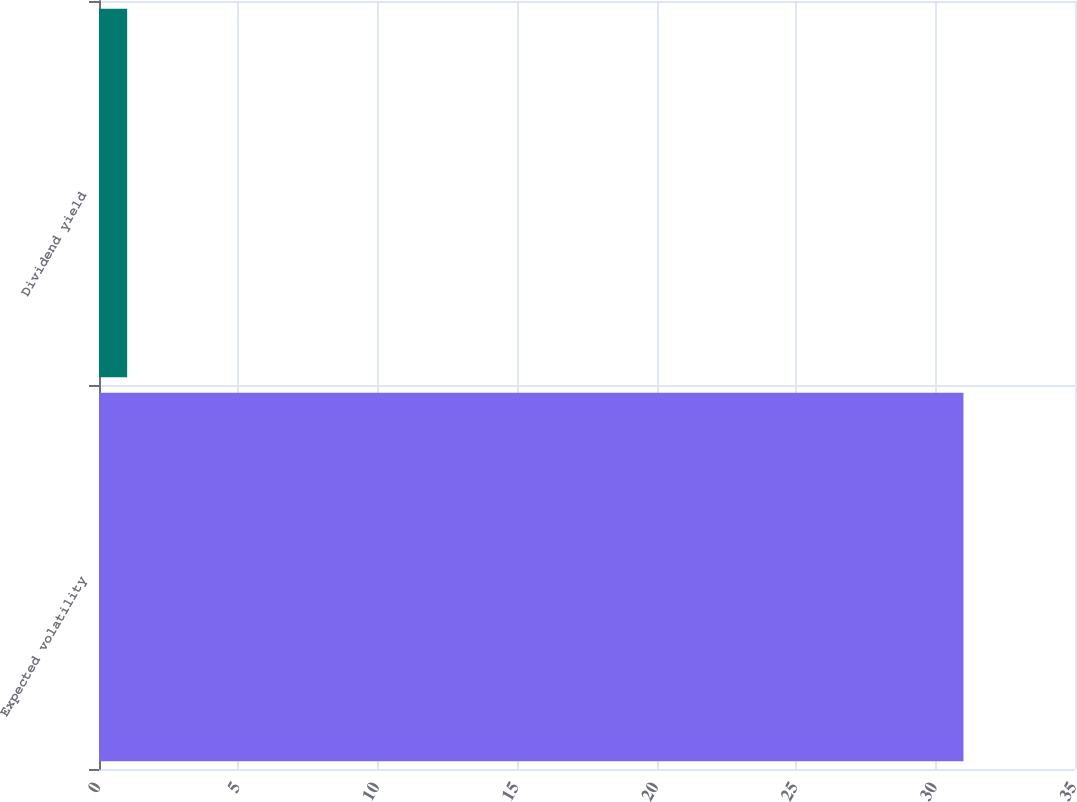Convert chart. <chart><loc_0><loc_0><loc_500><loc_500><bar_chart><fcel>Expected volatility<fcel>Dividend yield<nl><fcel>31<fcel>1.01<nl></chart> 